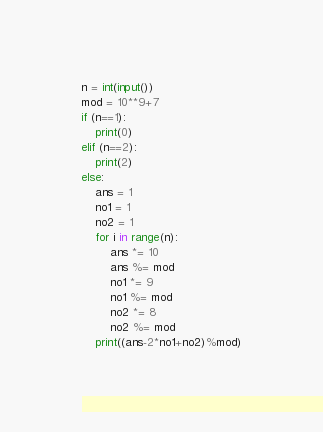Convert code to text. <code><loc_0><loc_0><loc_500><loc_500><_Python_>n = int(input())
mod = 10**9+7
if (n==1):
    print(0)
elif (n==2):
    print(2)
else:
    ans = 1
    no1 = 1
    no2 = 1
    for i in range(n):
        ans *= 10
        ans %= mod
        no1 *= 9
        no1 %= mod
        no2 *= 8
        no2 %= mod
    print((ans-2*no1+no2)%mod)</code> 